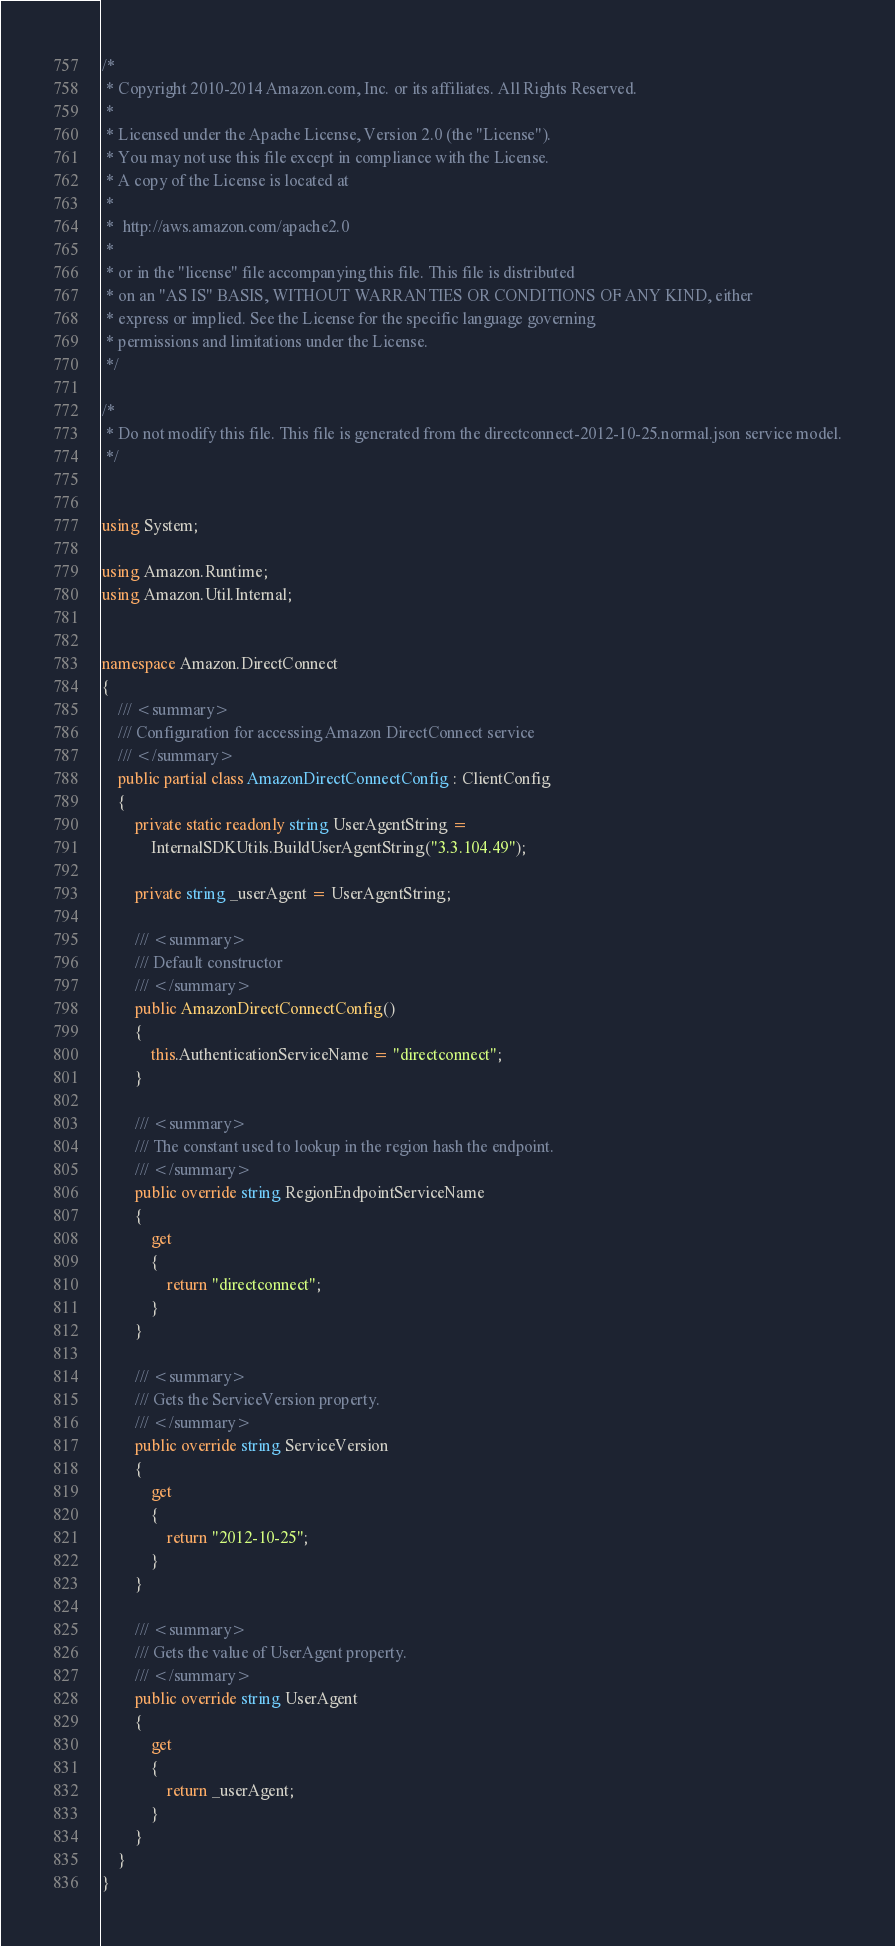<code> <loc_0><loc_0><loc_500><loc_500><_C#_>/*
 * Copyright 2010-2014 Amazon.com, Inc. or its affiliates. All Rights Reserved.
 * 
 * Licensed under the Apache License, Version 2.0 (the "License").
 * You may not use this file except in compliance with the License.
 * A copy of the License is located at
 * 
 *  http://aws.amazon.com/apache2.0
 * 
 * or in the "license" file accompanying this file. This file is distributed
 * on an "AS IS" BASIS, WITHOUT WARRANTIES OR CONDITIONS OF ANY KIND, either
 * express or implied. See the License for the specific language governing
 * permissions and limitations under the License.
 */

/*
 * Do not modify this file. This file is generated from the directconnect-2012-10-25.normal.json service model.
 */


using System;

using Amazon.Runtime;
using Amazon.Util.Internal;


namespace Amazon.DirectConnect
{
    /// <summary>
    /// Configuration for accessing Amazon DirectConnect service
    /// </summary>
    public partial class AmazonDirectConnectConfig : ClientConfig
    {
        private static readonly string UserAgentString =
            InternalSDKUtils.BuildUserAgentString("3.3.104.49");

        private string _userAgent = UserAgentString;

        /// <summary>
        /// Default constructor
        /// </summary>
        public AmazonDirectConnectConfig()
        {
            this.AuthenticationServiceName = "directconnect";
        }

        /// <summary>
        /// The constant used to lookup in the region hash the endpoint.
        /// </summary>
        public override string RegionEndpointServiceName
        {
            get
            {
                return "directconnect";
            }
        }

        /// <summary>
        /// Gets the ServiceVersion property.
        /// </summary>
        public override string ServiceVersion
        {
            get
            {
                return "2012-10-25";
            }
        }

        /// <summary>
        /// Gets the value of UserAgent property.
        /// </summary>
        public override string UserAgent
        {
            get
            {
                return _userAgent;
            }
        }
    }
}</code> 